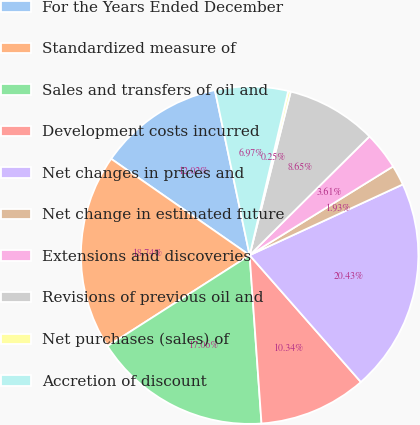<chart> <loc_0><loc_0><loc_500><loc_500><pie_chart><fcel>For the Years Ended December<fcel>Standardized measure of<fcel>Sales and transfers of oil and<fcel>Development costs incurred<fcel>Net changes in prices and<fcel>Net change in estimated future<fcel>Extensions and discoveries<fcel>Revisions of previous oil and<fcel>Net purchases (sales) of<fcel>Accretion of discount<nl><fcel>12.02%<fcel>18.74%<fcel>17.06%<fcel>10.34%<fcel>20.43%<fcel>1.93%<fcel>3.61%<fcel>8.65%<fcel>0.25%<fcel>6.97%<nl></chart> 